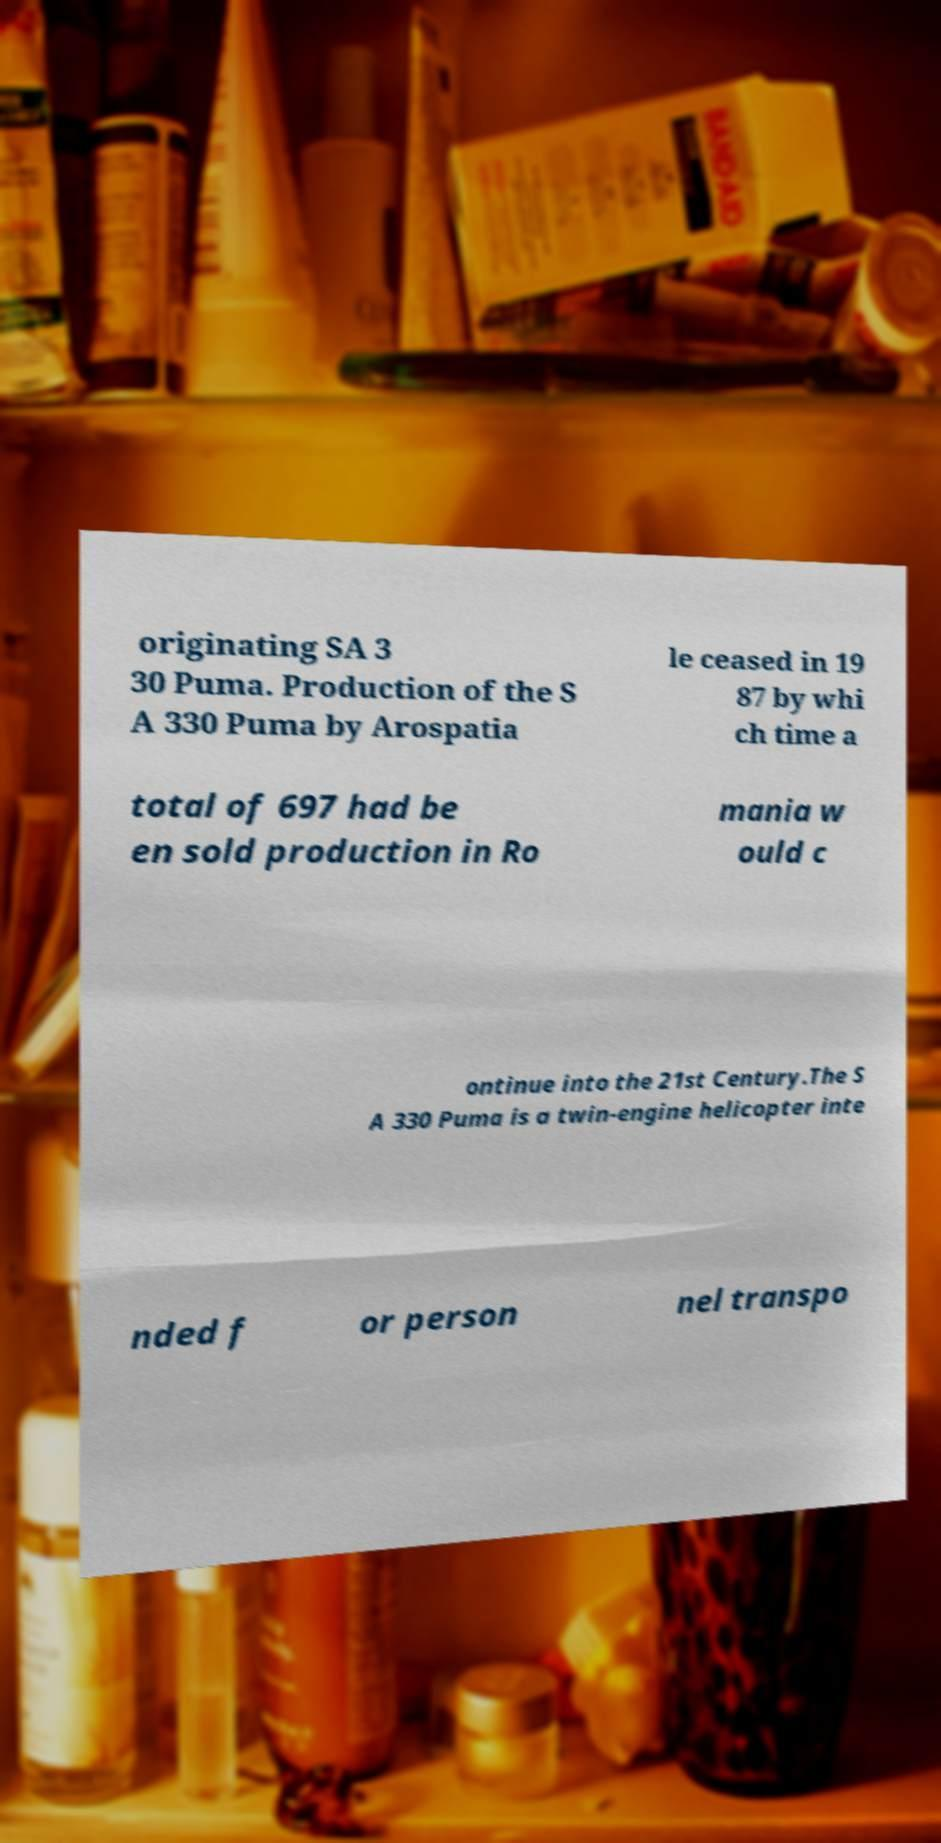Please identify and transcribe the text found in this image. originating SA 3 30 Puma. Production of the S A 330 Puma by Arospatia le ceased in 19 87 by whi ch time a total of 697 had be en sold production in Ro mania w ould c ontinue into the 21st Century.The S A 330 Puma is a twin-engine helicopter inte nded f or person nel transpo 